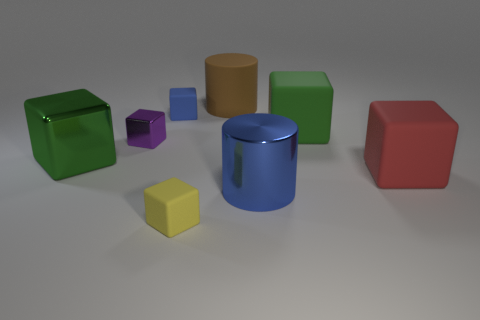Can you describe the arrangement of objects based on their sizes? Certainly! The objects in the image are arranged in no particular order based on size. We have a diverse set, from the smallest yellow cube to the largest green cube and cylinder shapes that vary in height. This creates a playful variety in scale and form. 